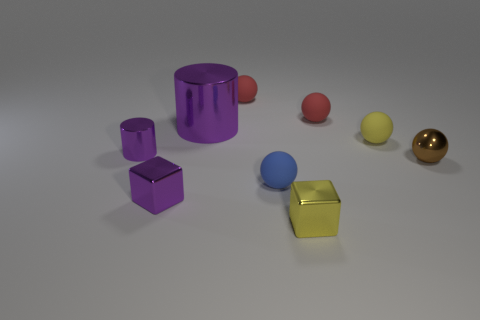The metal block that is the same color as the large cylinder is what size?
Give a very brief answer. Small. What number of other objects are the same color as the tiny shiny cylinder?
Your response must be concise. 2. There is a tiny blue object in front of the yellow matte sphere; does it have the same shape as the yellow shiny object in front of the tiny purple metal cube?
Offer a terse response. No. Do the big cylinder and the small cylinder have the same color?
Keep it short and to the point. Yes. What number of rubber things are behind the blue thing?
Your answer should be compact. 3. What number of tiny things are both to the right of the small purple metal cylinder and to the left of the small brown metal sphere?
Your answer should be compact. 6. There is a small yellow thing that is the same material as the purple block; what is its shape?
Your response must be concise. Cube. Is the size of the matte object that is in front of the small cylinder the same as the yellow object that is behind the brown thing?
Provide a succinct answer. Yes. What is the color of the metallic cylinder in front of the yellow matte sphere?
Your response must be concise. Purple. What is the material of the block that is behind the tiny metallic cube right of the large metallic object?
Your response must be concise. Metal. 